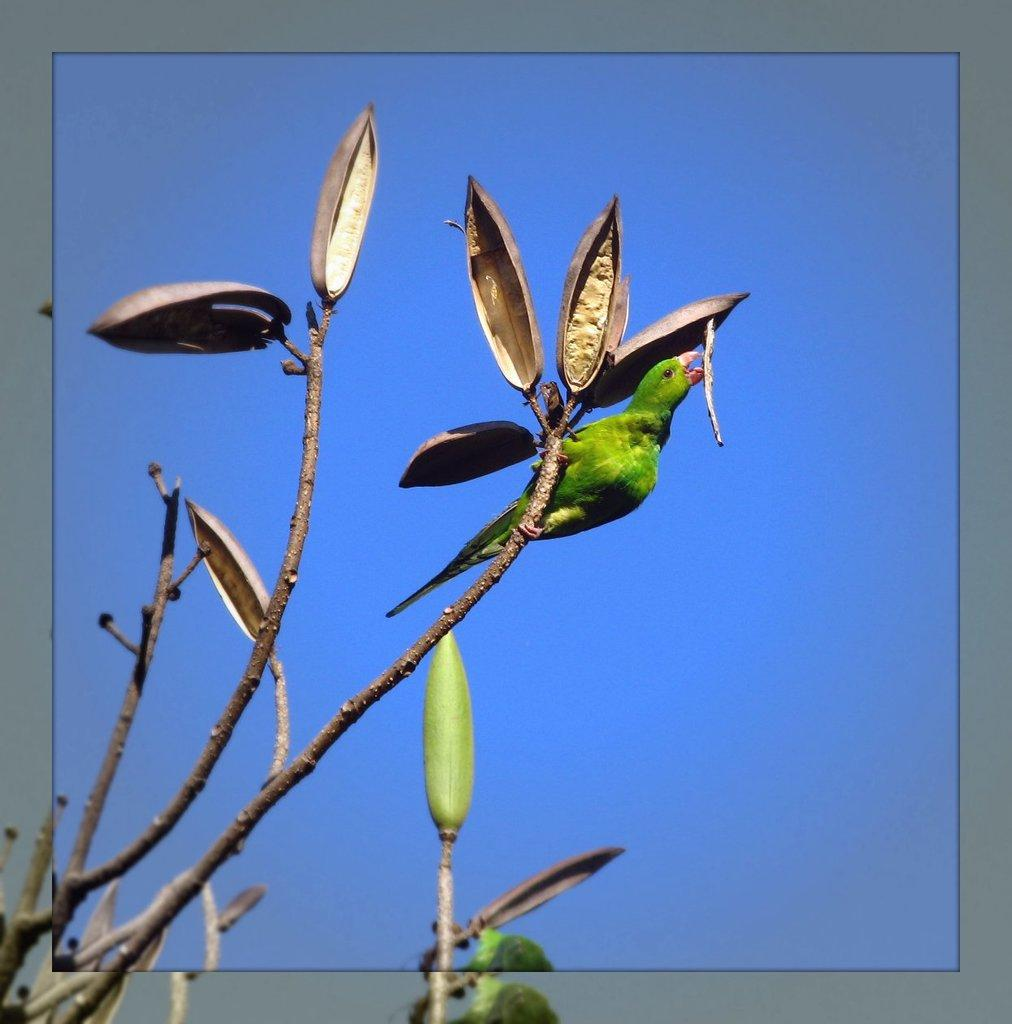What animal can be seen in the image? There is a bird on a tree in the image. What is the bird perched on? The bird is perched on a tree. What can be seen in the background of the image? There is a sky visible in the background of the image. How many jellyfish are swimming in the eggnog in the image? There are no jellyfish or eggnog present in the image; it features a bird on a tree with a sky background. 